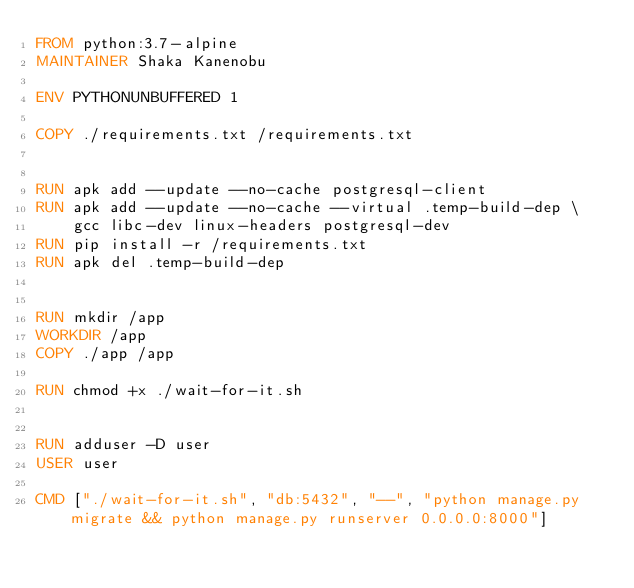<code> <loc_0><loc_0><loc_500><loc_500><_Dockerfile_>FROM python:3.7-alpine
MAINTAINER Shaka Kanenobu

ENV PYTHONUNBUFFERED 1

COPY ./requirements.txt /requirements.txt


RUN apk add --update --no-cache postgresql-client
RUN apk add --update --no-cache --virtual .temp-build-dep \ 
    gcc libc-dev linux-headers postgresql-dev
RUN pip install -r /requirements.txt
RUN apk del .temp-build-dep


RUN mkdir /app
WORKDIR /app
COPY ./app /app

RUN chmod +x ./wait-for-it.sh


RUN adduser -D user
USER user

CMD ["./wait-for-it.sh", "db:5432", "--", "python manage.py migrate && python manage.py runserver 0.0.0.0:8000"]</code> 